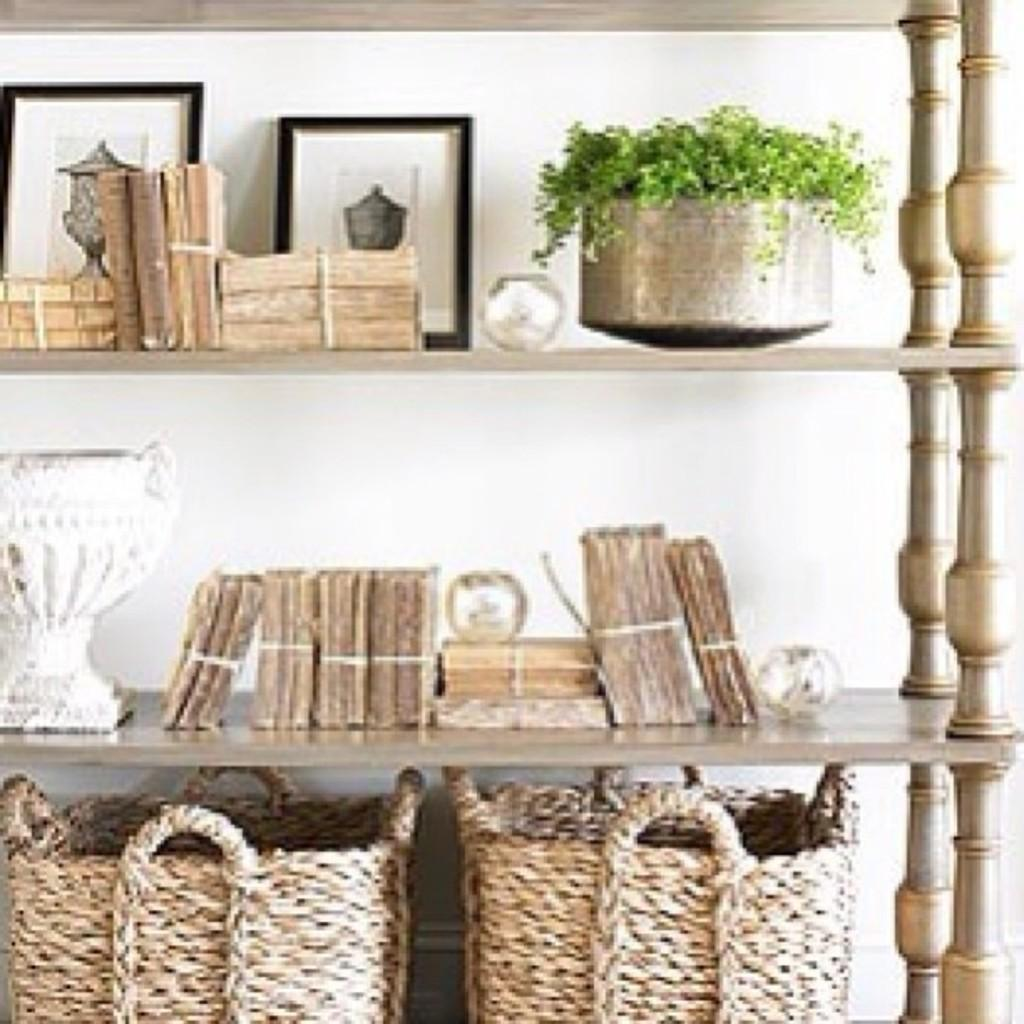What type of containers are present in the image? There are baskets in the image. What else can be seen in the image besides baskets? There are books and a flower pot in the image. What is in the flower pot? There is a bowl with leaves in the image. How are the items arranged in the image? The items are placed in racks. What can be seen in the background of the image? There is a wall visible in the background of the image. What is the purpose of the yard in the image? There is no yard present in the image; it features baskets, books, a flower pot, and a bowl with leaves arranged in racks with a wall visible in the background. 